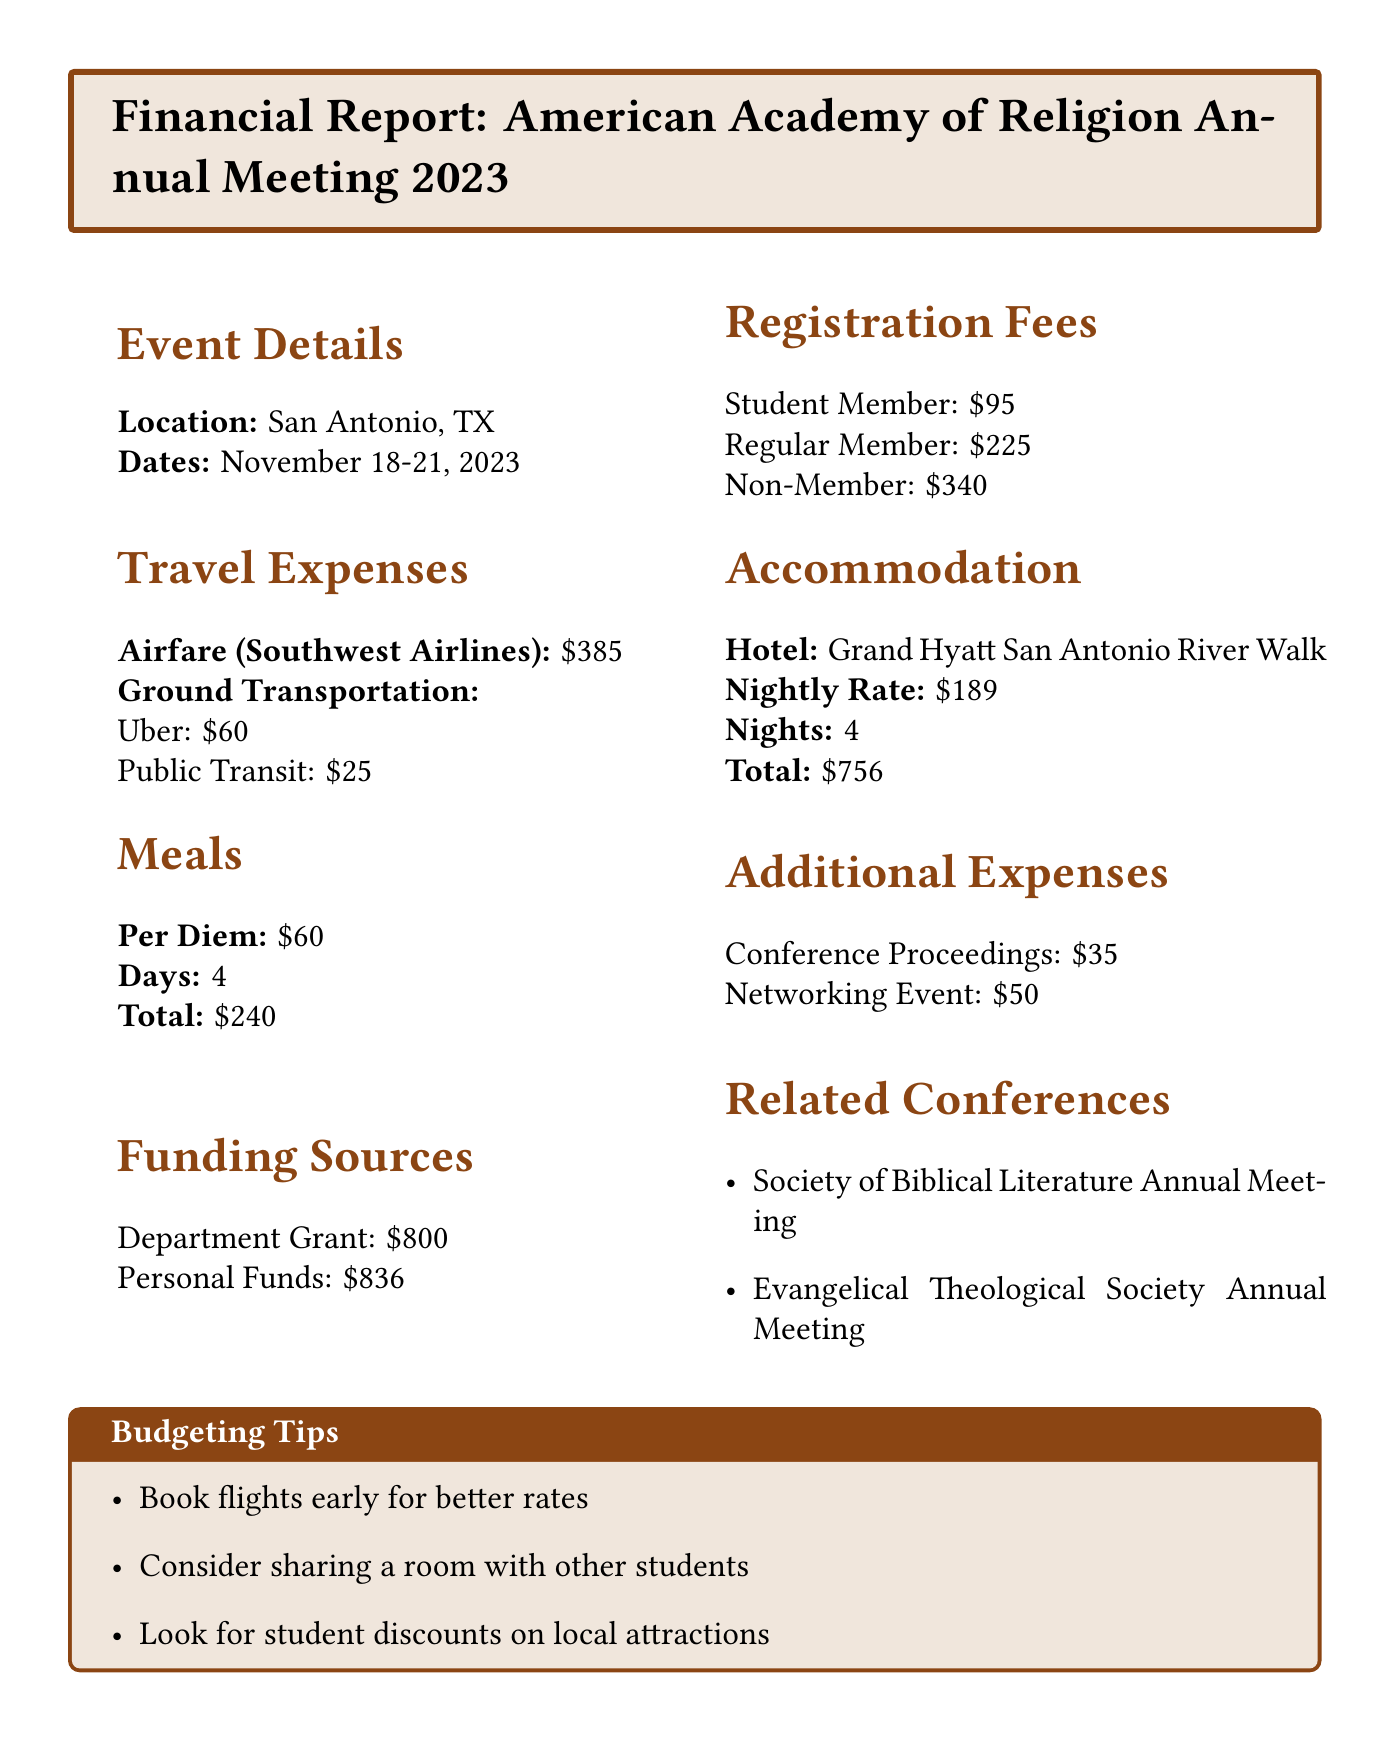What are the dates of the conference? The dates of the conference are provided in the document and are November 18-21, 2023.
Answer: November 18-21, 2023 What is the registration fee for a student member? The document lists the registration fees for different types of members, with the student member fee being specified as $95.
Answer: $95 How much is the total accommodation cost? The total accommodation cost is clearly stated as $756 in the accommodation section.
Answer: $756 What is the airfare cost with Southwest Airlines? The airfare cost for Southwest Airlines is mentioned in the travel expenses section as $385.
Answer: $385 What is the total amount of personal funds available? The funding sources section indicates that the total personal funds available are $836.
Answer: $836 If someone shares a room, how much could they save on accommodation? The document doesn’t specify the exact savings from sharing but implies that sharing could decrease costs. It mentions sharing a room as a budgeting tip.
Answer: Not specified What is the per diem amount for meals? The per diem amount is noted in the meals section as $60.
Answer: $60 Which hotel is listed for accommodation? The accommodation section names the hotel for the event, which is the Grand Hyatt San Antonio River Walk.
Answer: Grand Hyatt San Antonio River Walk How much funding is available from the department grant? The funding sources section states that the department grant available is $800.
Answer: $800 